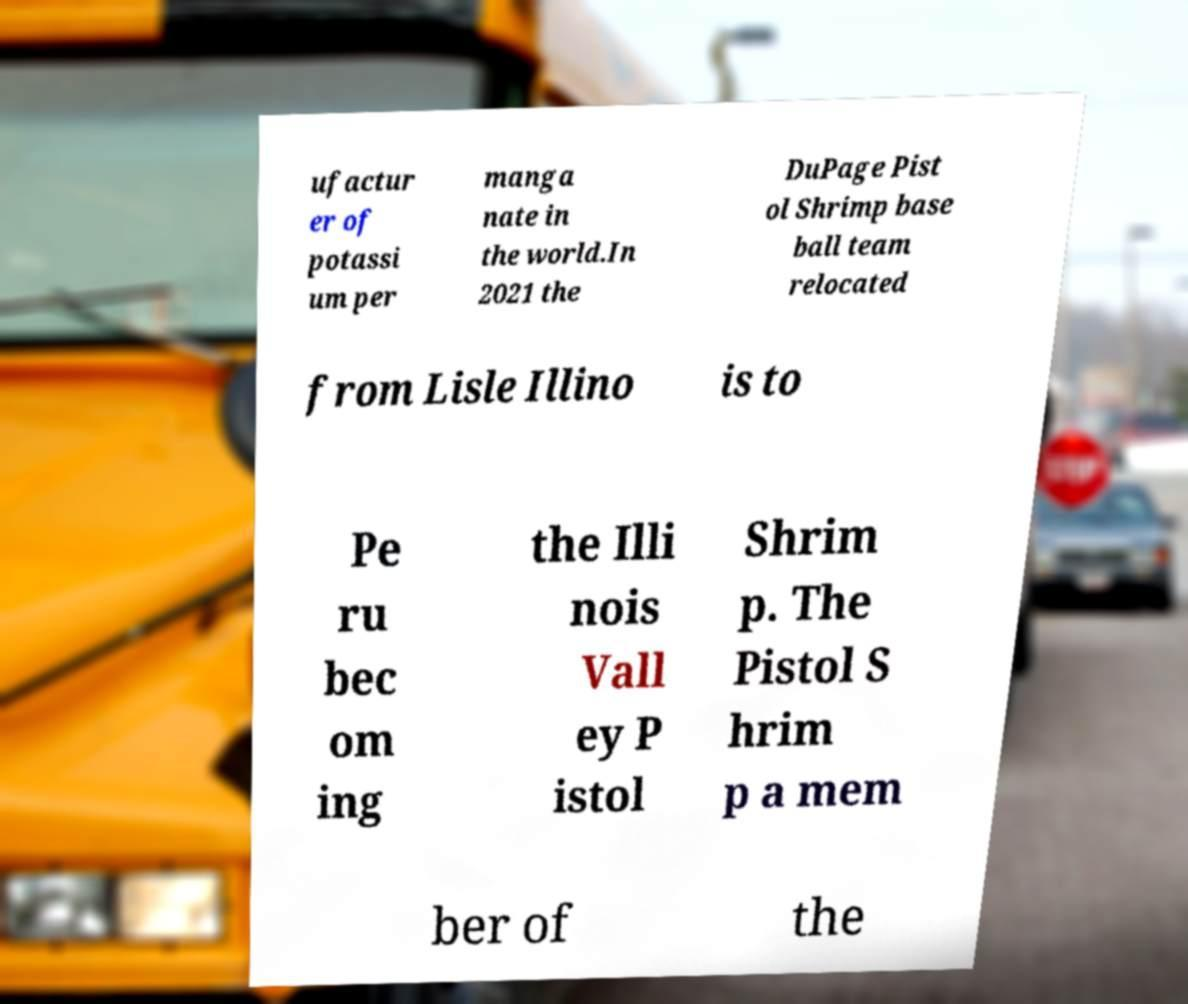Please read and relay the text visible in this image. What does it say? ufactur er of potassi um per manga nate in the world.In 2021 the DuPage Pist ol Shrimp base ball team relocated from Lisle Illino is to Pe ru bec om ing the Illi nois Vall ey P istol Shrim p. The Pistol S hrim p a mem ber of the 